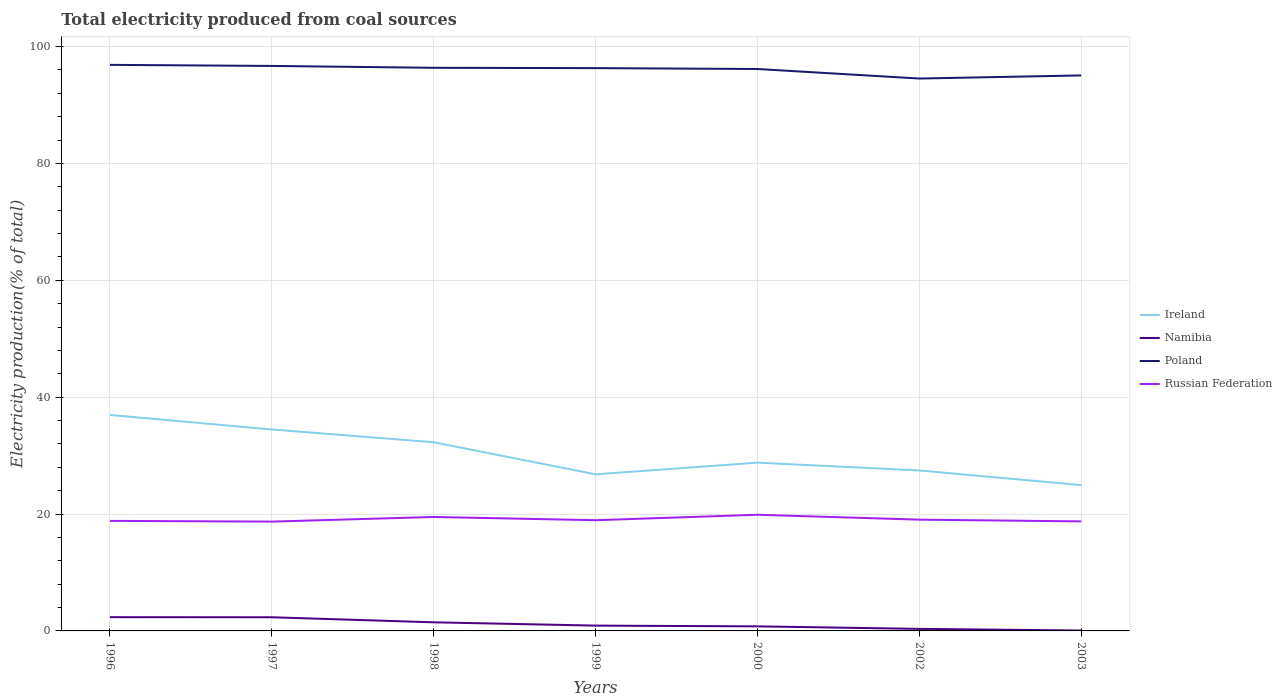How many different coloured lines are there?
Your answer should be compact. 4. Does the line corresponding to Ireland intersect with the line corresponding to Poland?
Offer a terse response. No. Is the number of lines equal to the number of legend labels?
Your answer should be compact. Yes. Across all years, what is the maximum total electricity produced in Namibia?
Provide a succinct answer. 0.07. What is the total total electricity produced in Namibia in the graph?
Provide a succinct answer. 0.69. What is the difference between the highest and the second highest total electricity produced in Poland?
Your answer should be very brief. 2.34. Is the total electricity produced in Ireland strictly greater than the total electricity produced in Poland over the years?
Your answer should be very brief. Yes. Does the graph contain grids?
Ensure brevity in your answer.  Yes. Where does the legend appear in the graph?
Provide a short and direct response. Center right. How many legend labels are there?
Provide a succinct answer. 4. What is the title of the graph?
Your answer should be very brief. Total electricity produced from coal sources. What is the label or title of the X-axis?
Ensure brevity in your answer.  Years. What is the label or title of the Y-axis?
Your answer should be compact. Electricity production(% of total). What is the Electricity production(% of total) in Ireland in 1996?
Give a very brief answer. 36.96. What is the Electricity production(% of total) of Namibia in 1996?
Make the answer very short. 2.35. What is the Electricity production(% of total) of Poland in 1996?
Make the answer very short. 96.86. What is the Electricity production(% of total) in Russian Federation in 1996?
Your answer should be compact. 18.83. What is the Electricity production(% of total) in Ireland in 1997?
Your answer should be compact. 34.47. What is the Electricity production(% of total) in Namibia in 1997?
Give a very brief answer. 2.34. What is the Electricity production(% of total) in Poland in 1997?
Offer a very short reply. 96.68. What is the Electricity production(% of total) of Russian Federation in 1997?
Keep it short and to the point. 18.7. What is the Electricity production(% of total) in Ireland in 1998?
Make the answer very short. 32.28. What is the Electricity production(% of total) in Namibia in 1998?
Ensure brevity in your answer.  1.47. What is the Electricity production(% of total) in Poland in 1998?
Provide a short and direct response. 96.36. What is the Electricity production(% of total) of Russian Federation in 1998?
Your answer should be compact. 19.5. What is the Electricity production(% of total) in Ireland in 1999?
Keep it short and to the point. 26.8. What is the Electricity production(% of total) in Namibia in 1999?
Provide a succinct answer. 0.91. What is the Electricity production(% of total) in Poland in 1999?
Keep it short and to the point. 96.3. What is the Electricity production(% of total) in Russian Federation in 1999?
Offer a terse response. 18.94. What is the Electricity production(% of total) in Ireland in 2000?
Your answer should be very brief. 28.8. What is the Electricity production(% of total) of Namibia in 2000?
Ensure brevity in your answer.  0.78. What is the Electricity production(% of total) of Poland in 2000?
Your answer should be very brief. 96.15. What is the Electricity production(% of total) in Russian Federation in 2000?
Your answer should be compact. 19.88. What is the Electricity production(% of total) of Ireland in 2002?
Give a very brief answer. 27.46. What is the Electricity production(% of total) of Namibia in 2002?
Provide a short and direct response. 0.35. What is the Electricity production(% of total) of Poland in 2002?
Your response must be concise. 94.52. What is the Electricity production(% of total) in Russian Federation in 2002?
Give a very brief answer. 19.04. What is the Electricity production(% of total) in Ireland in 2003?
Your answer should be very brief. 24.95. What is the Electricity production(% of total) of Namibia in 2003?
Your answer should be compact. 0.07. What is the Electricity production(% of total) of Poland in 2003?
Your answer should be very brief. 95.06. What is the Electricity production(% of total) of Russian Federation in 2003?
Your answer should be compact. 18.74. Across all years, what is the maximum Electricity production(% of total) of Ireland?
Offer a terse response. 36.96. Across all years, what is the maximum Electricity production(% of total) of Namibia?
Provide a short and direct response. 2.35. Across all years, what is the maximum Electricity production(% of total) of Poland?
Your answer should be compact. 96.86. Across all years, what is the maximum Electricity production(% of total) of Russian Federation?
Your answer should be very brief. 19.88. Across all years, what is the minimum Electricity production(% of total) in Ireland?
Offer a terse response. 24.95. Across all years, what is the minimum Electricity production(% of total) of Namibia?
Your response must be concise. 0.07. Across all years, what is the minimum Electricity production(% of total) of Poland?
Your answer should be compact. 94.52. Across all years, what is the minimum Electricity production(% of total) of Russian Federation?
Give a very brief answer. 18.7. What is the total Electricity production(% of total) of Ireland in the graph?
Offer a terse response. 211.71. What is the total Electricity production(% of total) in Namibia in the graph?
Your answer should be compact. 8.27. What is the total Electricity production(% of total) of Poland in the graph?
Your answer should be compact. 671.93. What is the total Electricity production(% of total) of Russian Federation in the graph?
Your answer should be compact. 133.64. What is the difference between the Electricity production(% of total) in Ireland in 1996 and that in 1997?
Make the answer very short. 2.48. What is the difference between the Electricity production(% of total) in Namibia in 1996 and that in 1997?
Give a very brief answer. 0.02. What is the difference between the Electricity production(% of total) in Poland in 1996 and that in 1997?
Offer a terse response. 0.18. What is the difference between the Electricity production(% of total) of Russian Federation in 1996 and that in 1997?
Provide a succinct answer. 0.13. What is the difference between the Electricity production(% of total) in Ireland in 1996 and that in 1998?
Your answer should be very brief. 4.67. What is the difference between the Electricity production(% of total) of Namibia in 1996 and that in 1998?
Your response must be concise. 0.88. What is the difference between the Electricity production(% of total) in Poland in 1996 and that in 1998?
Provide a succinct answer. 0.5. What is the difference between the Electricity production(% of total) of Russian Federation in 1996 and that in 1998?
Offer a very short reply. -0.67. What is the difference between the Electricity production(% of total) in Ireland in 1996 and that in 1999?
Keep it short and to the point. 10.16. What is the difference between the Electricity production(% of total) in Namibia in 1996 and that in 1999?
Offer a very short reply. 1.44. What is the difference between the Electricity production(% of total) of Poland in 1996 and that in 1999?
Provide a succinct answer. 0.56. What is the difference between the Electricity production(% of total) in Russian Federation in 1996 and that in 1999?
Keep it short and to the point. -0.11. What is the difference between the Electricity production(% of total) in Ireland in 1996 and that in 2000?
Make the answer very short. 8.16. What is the difference between the Electricity production(% of total) of Namibia in 1996 and that in 2000?
Provide a succinct answer. 1.57. What is the difference between the Electricity production(% of total) of Poland in 1996 and that in 2000?
Provide a short and direct response. 0.71. What is the difference between the Electricity production(% of total) in Russian Federation in 1996 and that in 2000?
Keep it short and to the point. -1.05. What is the difference between the Electricity production(% of total) of Ireland in 1996 and that in 2002?
Provide a succinct answer. 9.5. What is the difference between the Electricity production(% of total) of Namibia in 1996 and that in 2002?
Ensure brevity in your answer.  2. What is the difference between the Electricity production(% of total) of Poland in 1996 and that in 2002?
Give a very brief answer. 2.34. What is the difference between the Electricity production(% of total) in Russian Federation in 1996 and that in 2002?
Offer a terse response. -0.21. What is the difference between the Electricity production(% of total) of Ireland in 1996 and that in 2003?
Give a very brief answer. 12. What is the difference between the Electricity production(% of total) in Namibia in 1996 and that in 2003?
Provide a succinct answer. 2.28. What is the difference between the Electricity production(% of total) in Poland in 1996 and that in 2003?
Provide a succinct answer. 1.81. What is the difference between the Electricity production(% of total) of Russian Federation in 1996 and that in 2003?
Your answer should be very brief. 0.09. What is the difference between the Electricity production(% of total) of Ireland in 1997 and that in 1998?
Keep it short and to the point. 2.19. What is the difference between the Electricity production(% of total) of Namibia in 1997 and that in 1998?
Keep it short and to the point. 0.86. What is the difference between the Electricity production(% of total) in Poland in 1997 and that in 1998?
Provide a short and direct response. 0.32. What is the difference between the Electricity production(% of total) in Russian Federation in 1997 and that in 1998?
Keep it short and to the point. -0.79. What is the difference between the Electricity production(% of total) of Ireland in 1997 and that in 1999?
Offer a very short reply. 7.68. What is the difference between the Electricity production(% of total) of Namibia in 1997 and that in 1999?
Offer a terse response. 1.43. What is the difference between the Electricity production(% of total) in Russian Federation in 1997 and that in 1999?
Ensure brevity in your answer.  -0.24. What is the difference between the Electricity production(% of total) in Ireland in 1997 and that in 2000?
Offer a terse response. 5.67. What is the difference between the Electricity production(% of total) in Namibia in 1997 and that in 2000?
Keep it short and to the point. 1.55. What is the difference between the Electricity production(% of total) of Poland in 1997 and that in 2000?
Ensure brevity in your answer.  0.52. What is the difference between the Electricity production(% of total) of Russian Federation in 1997 and that in 2000?
Offer a terse response. -1.17. What is the difference between the Electricity production(% of total) in Ireland in 1997 and that in 2002?
Your answer should be very brief. 7.01. What is the difference between the Electricity production(% of total) of Namibia in 1997 and that in 2002?
Offer a very short reply. 1.99. What is the difference between the Electricity production(% of total) of Poland in 1997 and that in 2002?
Offer a very short reply. 2.16. What is the difference between the Electricity production(% of total) in Russian Federation in 1997 and that in 2002?
Keep it short and to the point. -0.33. What is the difference between the Electricity production(% of total) of Ireland in 1997 and that in 2003?
Your answer should be compact. 9.52. What is the difference between the Electricity production(% of total) of Namibia in 1997 and that in 2003?
Give a very brief answer. 2.27. What is the difference between the Electricity production(% of total) in Poland in 1997 and that in 2003?
Make the answer very short. 1.62. What is the difference between the Electricity production(% of total) of Russian Federation in 1997 and that in 2003?
Ensure brevity in your answer.  -0.04. What is the difference between the Electricity production(% of total) of Ireland in 1998 and that in 1999?
Offer a very short reply. 5.49. What is the difference between the Electricity production(% of total) in Namibia in 1998 and that in 1999?
Make the answer very short. 0.56. What is the difference between the Electricity production(% of total) in Poland in 1998 and that in 1999?
Your answer should be very brief. 0.06. What is the difference between the Electricity production(% of total) of Russian Federation in 1998 and that in 1999?
Your answer should be compact. 0.55. What is the difference between the Electricity production(% of total) of Ireland in 1998 and that in 2000?
Give a very brief answer. 3.49. What is the difference between the Electricity production(% of total) of Namibia in 1998 and that in 2000?
Provide a succinct answer. 0.69. What is the difference between the Electricity production(% of total) of Poland in 1998 and that in 2000?
Ensure brevity in your answer.  0.21. What is the difference between the Electricity production(% of total) in Russian Federation in 1998 and that in 2000?
Ensure brevity in your answer.  -0.38. What is the difference between the Electricity production(% of total) of Ireland in 1998 and that in 2002?
Make the answer very short. 4.83. What is the difference between the Electricity production(% of total) in Namibia in 1998 and that in 2002?
Give a very brief answer. 1.12. What is the difference between the Electricity production(% of total) in Poland in 1998 and that in 2002?
Make the answer very short. 1.84. What is the difference between the Electricity production(% of total) in Russian Federation in 1998 and that in 2002?
Your response must be concise. 0.46. What is the difference between the Electricity production(% of total) of Ireland in 1998 and that in 2003?
Keep it short and to the point. 7.33. What is the difference between the Electricity production(% of total) of Namibia in 1998 and that in 2003?
Keep it short and to the point. 1.4. What is the difference between the Electricity production(% of total) of Poland in 1998 and that in 2003?
Provide a short and direct response. 1.3. What is the difference between the Electricity production(% of total) of Russian Federation in 1998 and that in 2003?
Give a very brief answer. 0.76. What is the difference between the Electricity production(% of total) of Ireland in 1999 and that in 2000?
Ensure brevity in your answer.  -2. What is the difference between the Electricity production(% of total) of Namibia in 1999 and that in 2000?
Offer a very short reply. 0.13. What is the difference between the Electricity production(% of total) in Poland in 1999 and that in 2000?
Your response must be concise. 0.15. What is the difference between the Electricity production(% of total) of Russian Federation in 1999 and that in 2000?
Offer a very short reply. -0.93. What is the difference between the Electricity production(% of total) in Ireland in 1999 and that in 2002?
Offer a very short reply. -0.66. What is the difference between the Electricity production(% of total) of Namibia in 1999 and that in 2002?
Your answer should be very brief. 0.56. What is the difference between the Electricity production(% of total) of Poland in 1999 and that in 2002?
Offer a very short reply. 1.78. What is the difference between the Electricity production(% of total) of Russian Federation in 1999 and that in 2002?
Offer a terse response. -0.09. What is the difference between the Electricity production(% of total) in Ireland in 1999 and that in 2003?
Provide a short and direct response. 1.84. What is the difference between the Electricity production(% of total) in Namibia in 1999 and that in 2003?
Give a very brief answer. 0.84. What is the difference between the Electricity production(% of total) in Poland in 1999 and that in 2003?
Offer a terse response. 1.25. What is the difference between the Electricity production(% of total) of Russian Federation in 1999 and that in 2003?
Your answer should be compact. 0.2. What is the difference between the Electricity production(% of total) of Ireland in 2000 and that in 2002?
Provide a short and direct response. 1.34. What is the difference between the Electricity production(% of total) in Namibia in 2000 and that in 2002?
Your answer should be very brief. 0.43. What is the difference between the Electricity production(% of total) in Poland in 2000 and that in 2002?
Provide a succinct answer. 1.63. What is the difference between the Electricity production(% of total) of Russian Federation in 2000 and that in 2002?
Offer a very short reply. 0.84. What is the difference between the Electricity production(% of total) in Ireland in 2000 and that in 2003?
Your answer should be very brief. 3.85. What is the difference between the Electricity production(% of total) in Namibia in 2000 and that in 2003?
Your response must be concise. 0.71. What is the difference between the Electricity production(% of total) in Poland in 2000 and that in 2003?
Your answer should be very brief. 1.1. What is the difference between the Electricity production(% of total) in Russian Federation in 2000 and that in 2003?
Offer a terse response. 1.14. What is the difference between the Electricity production(% of total) of Ireland in 2002 and that in 2003?
Provide a succinct answer. 2.51. What is the difference between the Electricity production(% of total) in Namibia in 2002 and that in 2003?
Offer a terse response. 0.28. What is the difference between the Electricity production(% of total) of Poland in 2002 and that in 2003?
Your answer should be compact. -0.53. What is the difference between the Electricity production(% of total) of Russian Federation in 2002 and that in 2003?
Make the answer very short. 0.3. What is the difference between the Electricity production(% of total) in Ireland in 1996 and the Electricity production(% of total) in Namibia in 1997?
Provide a short and direct response. 34.62. What is the difference between the Electricity production(% of total) in Ireland in 1996 and the Electricity production(% of total) in Poland in 1997?
Offer a very short reply. -59.72. What is the difference between the Electricity production(% of total) in Ireland in 1996 and the Electricity production(% of total) in Russian Federation in 1997?
Your response must be concise. 18.25. What is the difference between the Electricity production(% of total) of Namibia in 1996 and the Electricity production(% of total) of Poland in 1997?
Provide a short and direct response. -94.33. What is the difference between the Electricity production(% of total) in Namibia in 1996 and the Electricity production(% of total) in Russian Federation in 1997?
Give a very brief answer. -16.35. What is the difference between the Electricity production(% of total) of Poland in 1996 and the Electricity production(% of total) of Russian Federation in 1997?
Ensure brevity in your answer.  78.16. What is the difference between the Electricity production(% of total) of Ireland in 1996 and the Electricity production(% of total) of Namibia in 1998?
Provide a short and direct response. 35.48. What is the difference between the Electricity production(% of total) of Ireland in 1996 and the Electricity production(% of total) of Poland in 1998?
Keep it short and to the point. -59.4. What is the difference between the Electricity production(% of total) of Ireland in 1996 and the Electricity production(% of total) of Russian Federation in 1998?
Ensure brevity in your answer.  17.46. What is the difference between the Electricity production(% of total) of Namibia in 1996 and the Electricity production(% of total) of Poland in 1998?
Offer a terse response. -94.01. What is the difference between the Electricity production(% of total) in Namibia in 1996 and the Electricity production(% of total) in Russian Federation in 1998?
Keep it short and to the point. -17.15. What is the difference between the Electricity production(% of total) in Poland in 1996 and the Electricity production(% of total) in Russian Federation in 1998?
Your answer should be very brief. 77.36. What is the difference between the Electricity production(% of total) of Ireland in 1996 and the Electricity production(% of total) of Namibia in 1999?
Keep it short and to the point. 36.05. What is the difference between the Electricity production(% of total) of Ireland in 1996 and the Electricity production(% of total) of Poland in 1999?
Your response must be concise. -59.35. What is the difference between the Electricity production(% of total) of Ireland in 1996 and the Electricity production(% of total) of Russian Federation in 1999?
Offer a very short reply. 18.01. What is the difference between the Electricity production(% of total) in Namibia in 1996 and the Electricity production(% of total) in Poland in 1999?
Provide a short and direct response. -93.95. What is the difference between the Electricity production(% of total) in Namibia in 1996 and the Electricity production(% of total) in Russian Federation in 1999?
Your answer should be very brief. -16.59. What is the difference between the Electricity production(% of total) in Poland in 1996 and the Electricity production(% of total) in Russian Federation in 1999?
Provide a succinct answer. 77.92. What is the difference between the Electricity production(% of total) of Ireland in 1996 and the Electricity production(% of total) of Namibia in 2000?
Your answer should be compact. 36.17. What is the difference between the Electricity production(% of total) of Ireland in 1996 and the Electricity production(% of total) of Poland in 2000?
Your answer should be very brief. -59.2. What is the difference between the Electricity production(% of total) in Ireland in 1996 and the Electricity production(% of total) in Russian Federation in 2000?
Keep it short and to the point. 17.08. What is the difference between the Electricity production(% of total) in Namibia in 1996 and the Electricity production(% of total) in Poland in 2000?
Your answer should be compact. -93.8. What is the difference between the Electricity production(% of total) of Namibia in 1996 and the Electricity production(% of total) of Russian Federation in 2000?
Give a very brief answer. -17.53. What is the difference between the Electricity production(% of total) in Poland in 1996 and the Electricity production(% of total) in Russian Federation in 2000?
Your answer should be compact. 76.99. What is the difference between the Electricity production(% of total) in Ireland in 1996 and the Electricity production(% of total) in Namibia in 2002?
Keep it short and to the point. 36.61. What is the difference between the Electricity production(% of total) in Ireland in 1996 and the Electricity production(% of total) in Poland in 2002?
Your response must be concise. -57.57. What is the difference between the Electricity production(% of total) of Ireland in 1996 and the Electricity production(% of total) of Russian Federation in 2002?
Your answer should be compact. 17.92. What is the difference between the Electricity production(% of total) in Namibia in 1996 and the Electricity production(% of total) in Poland in 2002?
Your response must be concise. -92.17. What is the difference between the Electricity production(% of total) in Namibia in 1996 and the Electricity production(% of total) in Russian Federation in 2002?
Your response must be concise. -16.69. What is the difference between the Electricity production(% of total) in Poland in 1996 and the Electricity production(% of total) in Russian Federation in 2002?
Your response must be concise. 77.82. What is the difference between the Electricity production(% of total) of Ireland in 1996 and the Electricity production(% of total) of Namibia in 2003?
Provide a short and direct response. 36.89. What is the difference between the Electricity production(% of total) in Ireland in 1996 and the Electricity production(% of total) in Poland in 2003?
Your answer should be very brief. -58.1. What is the difference between the Electricity production(% of total) of Ireland in 1996 and the Electricity production(% of total) of Russian Federation in 2003?
Make the answer very short. 18.21. What is the difference between the Electricity production(% of total) of Namibia in 1996 and the Electricity production(% of total) of Poland in 2003?
Offer a terse response. -92.7. What is the difference between the Electricity production(% of total) of Namibia in 1996 and the Electricity production(% of total) of Russian Federation in 2003?
Provide a short and direct response. -16.39. What is the difference between the Electricity production(% of total) of Poland in 1996 and the Electricity production(% of total) of Russian Federation in 2003?
Give a very brief answer. 78.12. What is the difference between the Electricity production(% of total) of Ireland in 1997 and the Electricity production(% of total) of Namibia in 1998?
Offer a very short reply. 33. What is the difference between the Electricity production(% of total) in Ireland in 1997 and the Electricity production(% of total) in Poland in 1998?
Your response must be concise. -61.89. What is the difference between the Electricity production(% of total) in Ireland in 1997 and the Electricity production(% of total) in Russian Federation in 1998?
Provide a succinct answer. 14.97. What is the difference between the Electricity production(% of total) of Namibia in 1997 and the Electricity production(% of total) of Poland in 1998?
Your answer should be very brief. -94.02. What is the difference between the Electricity production(% of total) in Namibia in 1997 and the Electricity production(% of total) in Russian Federation in 1998?
Offer a terse response. -17.16. What is the difference between the Electricity production(% of total) in Poland in 1997 and the Electricity production(% of total) in Russian Federation in 1998?
Offer a terse response. 77.18. What is the difference between the Electricity production(% of total) in Ireland in 1997 and the Electricity production(% of total) in Namibia in 1999?
Your response must be concise. 33.56. What is the difference between the Electricity production(% of total) in Ireland in 1997 and the Electricity production(% of total) in Poland in 1999?
Provide a short and direct response. -61.83. What is the difference between the Electricity production(% of total) in Ireland in 1997 and the Electricity production(% of total) in Russian Federation in 1999?
Keep it short and to the point. 15.53. What is the difference between the Electricity production(% of total) in Namibia in 1997 and the Electricity production(% of total) in Poland in 1999?
Offer a terse response. -93.97. What is the difference between the Electricity production(% of total) of Namibia in 1997 and the Electricity production(% of total) of Russian Federation in 1999?
Give a very brief answer. -16.61. What is the difference between the Electricity production(% of total) in Poland in 1997 and the Electricity production(% of total) in Russian Federation in 1999?
Provide a succinct answer. 77.73. What is the difference between the Electricity production(% of total) in Ireland in 1997 and the Electricity production(% of total) in Namibia in 2000?
Provide a short and direct response. 33.69. What is the difference between the Electricity production(% of total) of Ireland in 1997 and the Electricity production(% of total) of Poland in 2000?
Keep it short and to the point. -61.68. What is the difference between the Electricity production(% of total) of Ireland in 1997 and the Electricity production(% of total) of Russian Federation in 2000?
Give a very brief answer. 14.59. What is the difference between the Electricity production(% of total) of Namibia in 1997 and the Electricity production(% of total) of Poland in 2000?
Offer a terse response. -93.82. What is the difference between the Electricity production(% of total) in Namibia in 1997 and the Electricity production(% of total) in Russian Federation in 2000?
Your response must be concise. -17.54. What is the difference between the Electricity production(% of total) in Poland in 1997 and the Electricity production(% of total) in Russian Federation in 2000?
Ensure brevity in your answer.  76.8. What is the difference between the Electricity production(% of total) in Ireland in 1997 and the Electricity production(% of total) in Namibia in 2002?
Provide a succinct answer. 34.12. What is the difference between the Electricity production(% of total) in Ireland in 1997 and the Electricity production(% of total) in Poland in 2002?
Provide a succinct answer. -60.05. What is the difference between the Electricity production(% of total) in Ireland in 1997 and the Electricity production(% of total) in Russian Federation in 2002?
Give a very brief answer. 15.43. What is the difference between the Electricity production(% of total) in Namibia in 1997 and the Electricity production(% of total) in Poland in 2002?
Offer a very short reply. -92.19. What is the difference between the Electricity production(% of total) of Namibia in 1997 and the Electricity production(% of total) of Russian Federation in 2002?
Your answer should be very brief. -16.7. What is the difference between the Electricity production(% of total) of Poland in 1997 and the Electricity production(% of total) of Russian Federation in 2002?
Keep it short and to the point. 77.64. What is the difference between the Electricity production(% of total) of Ireland in 1997 and the Electricity production(% of total) of Namibia in 2003?
Provide a succinct answer. 34.4. What is the difference between the Electricity production(% of total) in Ireland in 1997 and the Electricity production(% of total) in Poland in 2003?
Offer a very short reply. -60.58. What is the difference between the Electricity production(% of total) in Ireland in 1997 and the Electricity production(% of total) in Russian Federation in 2003?
Your response must be concise. 15.73. What is the difference between the Electricity production(% of total) in Namibia in 1997 and the Electricity production(% of total) in Poland in 2003?
Give a very brief answer. -92.72. What is the difference between the Electricity production(% of total) in Namibia in 1997 and the Electricity production(% of total) in Russian Federation in 2003?
Offer a terse response. -16.4. What is the difference between the Electricity production(% of total) of Poland in 1997 and the Electricity production(% of total) of Russian Federation in 2003?
Offer a terse response. 77.94. What is the difference between the Electricity production(% of total) of Ireland in 1998 and the Electricity production(% of total) of Namibia in 1999?
Ensure brevity in your answer.  31.37. What is the difference between the Electricity production(% of total) of Ireland in 1998 and the Electricity production(% of total) of Poland in 1999?
Your answer should be very brief. -64.02. What is the difference between the Electricity production(% of total) of Ireland in 1998 and the Electricity production(% of total) of Russian Federation in 1999?
Ensure brevity in your answer.  13.34. What is the difference between the Electricity production(% of total) in Namibia in 1998 and the Electricity production(% of total) in Poland in 1999?
Your answer should be compact. -94.83. What is the difference between the Electricity production(% of total) in Namibia in 1998 and the Electricity production(% of total) in Russian Federation in 1999?
Your answer should be very brief. -17.47. What is the difference between the Electricity production(% of total) of Poland in 1998 and the Electricity production(% of total) of Russian Federation in 1999?
Ensure brevity in your answer.  77.41. What is the difference between the Electricity production(% of total) of Ireland in 1998 and the Electricity production(% of total) of Namibia in 2000?
Your answer should be compact. 31.5. What is the difference between the Electricity production(% of total) in Ireland in 1998 and the Electricity production(% of total) in Poland in 2000?
Keep it short and to the point. -63.87. What is the difference between the Electricity production(% of total) in Ireland in 1998 and the Electricity production(% of total) in Russian Federation in 2000?
Your answer should be compact. 12.41. What is the difference between the Electricity production(% of total) of Namibia in 1998 and the Electricity production(% of total) of Poland in 2000?
Offer a terse response. -94.68. What is the difference between the Electricity production(% of total) of Namibia in 1998 and the Electricity production(% of total) of Russian Federation in 2000?
Your answer should be very brief. -18.41. What is the difference between the Electricity production(% of total) in Poland in 1998 and the Electricity production(% of total) in Russian Federation in 2000?
Ensure brevity in your answer.  76.48. What is the difference between the Electricity production(% of total) in Ireland in 1998 and the Electricity production(% of total) in Namibia in 2002?
Ensure brevity in your answer.  31.93. What is the difference between the Electricity production(% of total) of Ireland in 1998 and the Electricity production(% of total) of Poland in 2002?
Offer a terse response. -62.24. What is the difference between the Electricity production(% of total) of Ireland in 1998 and the Electricity production(% of total) of Russian Federation in 2002?
Keep it short and to the point. 13.24. What is the difference between the Electricity production(% of total) of Namibia in 1998 and the Electricity production(% of total) of Poland in 2002?
Your answer should be very brief. -93.05. What is the difference between the Electricity production(% of total) of Namibia in 1998 and the Electricity production(% of total) of Russian Federation in 2002?
Offer a very short reply. -17.57. What is the difference between the Electricity production(% of total) in Poland in 1998 and the Electricity production(% of total) in Russian Federation in 2002?
Offer a very short reply. 77.32. What is the difference between the Electricity production(% of total) of Ireland in 1998 and the Electricity production(% of total) of Namibia in 2003?
Provide a short and direct response. 32.21. What is the difference between the Electricity production(% of total) in Ireland in 1998 and the Electricity production(% of total) in Poland in 2003?
Keep it short and to the point. -62.77. What is the difference between the Electricity production(% of total) of Ireland in 1998 and the Electricity production(% of total) of Russian Federation in 2003?
Offer a terse response. 13.54. What is the difference between the Electricity production(% of total) of Namibia in 1998 and the Electricity production(% of total) of Poland in 2003?
Give a very brief answer. -93.58. What is the difference between the Electricity production(% of total) in Namibia in 1998 and the Electricity production(% of total) in Russian Federation in 2003?
Your response must be concise. -17.27. What is the difference between the Electricity production(% of total) in Poland in 1998 and the Electricity production(% of total) in Russian Federation in 2003?
Offer a very short reply. 77.62. What is the difference between the Electricity production(% of total) of Ireland in 1999 and the Electricity production(% of total) of Namibia in 2000?
Give a very brief answer. 26.01. What is the difference between the Electricity production(% of total) in Ireland in 1999 and the Electricity production(% of total) in Poland in 2000?
Your answer should be compact. -69.36. What is the difference between the Electricity production(% of total) in Ireland in 1999 and the Electricity production(% of total) in Russian Federation in 2000?
Your response must be concise. 6.92. What is the difference between the Electricity production(% of total) in Namibia in 1999 and the Electricity production(% of total) in Poland in 2000?
Your response must be concise. -95.24. What is the difference between the Electricity production(% of total) of Namibia in 1999 and the Electricity production(% of total) of Russian Federation in 2000?
Provide a short and direct response. -18.97. What is the difference between the Electricity production(% of total) in Poland in 1999 and the Electricity production(% of total) in Russian Federation in 2000?
Provide a succinct answer. 76.43. What is the difference between the Electricity production(% of total) of Ireland in 1999 and the Electricity production(% of total) of Namibia in 2002?
Offer a very short reply. 26.45. What is the difference between the Electricity production(% of total) in Ireland in 1999 and the Electricity production(% of total) in Poland in 2002?
Offer a terse response. -67.73. What is the difference between the Electricity production(% of total) of Ireland in 1999 and the Electricity production(% of total) of Russian Federation in 2002?
Your response must be concise. 7.76. What is the difference between the Electricity production(% of total) in Namibia in 1999 and the Electricity production(% of total) in Poland in 2002?
Provide a short and direct response. -93.61. What is the difference between the Electricity production(% of total) of Namibia in 1999 and the Electricity production(% of total) of Russian Federation in 2002?
Ensure brevity in your answer.  -18.13. What is the difference between the Electricity production(% of total) of Poland in 1999 and the Electricity production(% of total) of Russian Federation in 2002?
Provide a short and direct response. 77.26. What is the difference between the Electricity production(% of total) in Ireland in 1999 and the Electricity production(% of total) in Namibia in 2003?
Make the answer very short. 26.72. What is the difference between the Electricity production(% of total) in Ireland in 1999 and the Electricity production(% of total) in Poland in 2003?
Ensure brevity in your answer.  -68.26. What is the difference between the Electricity production(% of total) in Ireland in 1999 and the Electricity production(% of total) in Russian Federation in 2003?
Give a very brief answer. 8.05. What is the difference between the Electricity production(% of total) in Namibia in 1999 and the Electricity production(% of total) in Poland in 2003?
Your answer should be compact. -94.15. What is the difference between the Electricity production(% of total) of Namibia in 1999 and the Electricity production(% of total) of Russian Federation in 2003?
Keep it short and to the point. -17.83. What is the difference between the Electricity production(% of total) in Poland in 1999 and the Electricity production(% of total) in Russian Federation in 2003?
Your answer should be very brief. 77.56. What is the difference between the Electricity production(% of total) of Ireland in 2000 and the Electricity production(% of total) of Namibia in 2002?
Your answer should be very brief. 28.45. What is the difference between the Electricity production(% of total) in Ireland in 2000 and the Electricity production(% of total) in Poland in 2002?
Ensure brevity in your answer.  -65.73. What is the difference between the Electricity production(% of total) in Ireland in 2000 and the Electricity production(% of total) in Russian Federation in 2002?
Offer a very short reply. 9.76. What is the difference between the Electricity production(% of total) of Namibia in 2000 and the Electricity production(% of total) of Poland in 2002?
Your answer should be very brief. -93.74. What is the difference between the Electricity production(% of total) in Namibia in 2000 and the Electricity production(% of total) in Russian Federation in 2002?
Give a very brief answer. -18.26. What is the difference between the Electricity production(% of total) in Poland in 2000 and the Electricity production(% of total) in Russian Federation in 2002?
Make the answer very short. 77.12. What is the difference between the Electricity production(% of total) in Ireland in 2000 and the Electricity production(% of total) in Namibia in 2003?
Your answer should be compact. 28.73. What is the difference between the Electricity production(% of total) of Ireland in 2000 and the Electricity production(% of total) of Poland in 2003?
Your answer should be compact. -66.26. What is the difference between the Electricity production(% of total) in Ireland in 2000 and the Electricity production(% of total) in Russian Federation in 2003?
Your response must be concise. 10.06. What is the difference between the Electricity production(% of total) of Namibia in 2000 and the Electricity production(% of total) of Poland in 2003?
Your response must be concise. -94.27. What is the difference between the Electricity production(% of total) of Namibia in 2000 and the Electricity production(% of total) of Russian Federation in 2003?
Your answer should be compact. -17.96. What is the difference between the Electricity production(% of total) in Poland in 2000 and the Electricity production(% of total) in Russian Federation in 2003?
Offer a terse response. 77.41. What is the difference between the Electricity production(% of total) in Ireland in 2002 and the Electricity production(% of total) in Namibia in 2003?
Provide a short and direct response. 27.39. What is the difference between the Electricity production(% of total) of Ireland in 2002 and the Electricity production(% of total) of Poland in 2003?
Ensure brevity in your answer.  -67.6. What is the difference between the Electricity production(% of total) in Ireland in 2002 and the Electricity production(% of total) in Russian Federation in 2003?
Offer a very short reply. 8.72. What is the difference between the Electricity production(% of total) in Namibia in 2002 and the Electricity production(% of total) in Poland in 2003?
Your answer should be compact. -94.71. What is the difference between the Electricity production(% of total) of Namibia in 2002 and the Electricity production(% of total) of Russian Federation in 2003?
Provide a succinct answer. -18.39. What is the difference between the Electricity production(% of total) in Poland in 2002 and the Electricity production(% of total) in Russian Federation in 2003?
Make the answer very short. 75.78. What is the average Electricity production(% of total) in Ireland per year?
Provide a succinct answer. 30.24. What is the average Electricity production(% of total) in Namibia per year?
Ensure brevity in your answer.  1.18. What is the average Electricity production(% of total) in Poland per year?
Ensure brevity in your answer.  95.99. What is the average Electricity production(% of total) in Russian Federation per year?
Your response must be concise. 19.09. In the year 1996, what is the difference between the Electricity production(% of total) in Ireland and Electricity production(% of total) in Namibia?
Provide a short and direct response. 34.6. In the year 1996, what is the difference between the Electricity production(% of total) of Ireland and Electricity production(% of total) of Poland?
Make the answer very short. -59.91. In the year 1996, what is the difference between the Electricity production(% of total) in Ireland and Electricity production(% of total) in Russian Federation?
Provide a short and direct response. 18.12. In the year 1996, what is the difference between the Electricity production(% of total) of Namibia and Electricity production(% of total) of Poland?
Your answer should be compact. -94.51. In the year 1996, what is the difference between the Electricity production(% of total) in Namibia and Electricity production(% of total) in Russian Federation?
Ensure brevity in your answer.  -16.48. In the year 1996, what is the difference between the Electricity production(% of total) of Poland and Electricity production(% of total) of Russian Federation?
Keep it short and to the point. 78.03. In the year 1997, what is the difference between the Electricity production(% of total) in Ireland and Electricity production(% of total) in Namibia?
Offer a terse response. 32.13. In the year 1997, what is the difference between the Electricity production(% of total) in Ireland and Electricity production(% of total) in Poland?
Give a very brief answer. -62.21. In the year 1997, what is the difference between the Electricity production(% of total) in Ireland and Electricity production(% of total) in Russian Federation?
Give a very brief answer. 15.77. In the year 1997, what is the difference between the Electricity production(% of total) in Namibia and Electricity production(% of total) in Poland?
Your answer should be compact. -94.34. In the year 1997, what is the difference between the Electricity production(% of total) of Namibia and Electricity production(% of total) of Russian Federation?
Give a very brief answer. -16.37. In the year 1997, what is the difference between the Electricity production(% of total) in Poland and Electricity production(% of total) in Russian Federation?
Ensure brevity in your answer.  77.97. In the year 1998, what is the difference between the Electricity production(% of total) in Ireland and Electricity production(% of total) in Namibia?
Ensure brevity in your answer.  30.81. In the year 1998, what is the difference between the Electricity production(% of total) in Ireland and Electricity production(% of total) in Poland?
Offer a terse response. -64.08. In the year 1998, what is the difference between the Electricity production(% of total) of Ireland and Electricity production(% of total) of Russian Federation?
Give a very brief answer. 12.78. In the year 1998, what is the difference between the Electricity production(% of total) in Namibia and Electricity production(% of total) in Poland?
Ensure brevity in your answer.  -94.89. In the year 1998, what is the difference between the Electricity production(% of total) of Namibia and Electricity production(% of total) of Russian Federation?
Provide a succinct answer. -18.03. In the year 1998, what is the difference between the Electricity production(% of total) in Poland and Electricity production(% of total) in Russian Federation?
Ensure brevity in your answer.  76.86. In the year 1999, what is the difference between the Electricity production(% of total) of Ireland and Electricity production(% of total) of Namibia?
Offer a very short reply. 25.89. In the year 1999, what is the difference between the Electricity production(% of total) in Ireland and Electricity production(% of total) in Poland?
Your answer should be very brief. -69.51. In the year 1999, what is the difference between the Electricity production(% of total) of Ireland and Electricity production(% of total) of Russian Federation?
Keep it short and to the point. 7.85. In the year 1999, what is the difference between the Electricity production(% of total) in Namibia and Electricity production(% of total) in Poland?
Your answer should be compact. -95.39. In the year 1999, what is the difference between the Electricity production(% of total) in Namibia and Electricity production(% of total) in Russian Federation?
Your answer should be compact. -18.03. In the year 1999, what is the difference between the Electricity production(% of total) of Poland and Electricity production(% of total) of Russian Federation?
Keep it short and to the point. 77.36. In the year 2000, what is the difference between the Electricity production(% of total) of Ireland and Electricity production(% of total) of Namibia?
Your answer should be compact. 28.01. In the year 2000, what is the difference between the Electricity production(% of total) of Ireland and Electricity production(% of total) of Poland?
Provide a succinct answer. -67.36. In the year 2000, what is the difference between the Electricity production(% of total) in Ireland and Electricity production(% of total) in Russian Federation?
Make the answer very short. 8.92. In the year 2000, what is the difference between the Electricity production(% of total) of Namibia and Electricity production(% of total) of Poland?
Keep it short and to the point. -95.37. In the year 2000, what is the difference between the Electricity production(% of total) of Namibia and Electricity production(% of total) of Russian Federation?
Provide a short and direct response. -19.1. In the year 2000, what is the difference between the Electricity production(% of total) in Poland and Electricity production(% of total) in Russian Federation?
Ensure brevity in your answer.  76.28. In the year 2002, what is the difference between the Electricity production(% of total) of Ireland and Electricity production(% of total) of Namibia?
Your answer should be very brief. 27.11. In the year 2002, what is the difference between the Electricity production(% of total) of Ireland and Electricity production(% of total) of Poland?
Provide a short and direct response. -67.07. In the year 2002, what is the difference between the Electricity production(% of total) of Ireland and Electricity production(% of total) of Russian Federation?
Make the answer very short. 8.42. In the year 2002, what is the difference between the Electricity production(% of total) of Namibia and Electricity production(% of total) of Poland?
Offer a very short reply. -94.17. In the year 2002, what is the difference between the Electricity production(% of total) of Namibia and Electricity production(% of total) of Russian Federation?
Ensure brevity in your answer.  -18.69. In the year 2002, what is the difference between the Electricity production(% of total) of Poland and Electricity production(% of total) of Russian Federation?
Offer a terse response. 75.48. In the year 2003, what is the difference between the Electricity production(% of total) in Ireland and Electricity production(% of total) in Namibia?
Your answer should be compact. 24.88. In the year 2003, what is the difference between the Electricity production(% of total) of Ireland and Electricity production(% of total) of Poland?
Ensure brevity in your answer.  -70.1. In the year 2003, what is the difference between the Electricity production(% of total) of Ireland and Electricity production(% of total) of Russian Federation?
Offer a terse response. 6.21. In the year 2003, what is the difference between the Electricity production(% of total) of Namibia and Electricity production(% of total) of Poland?
Ensure brevity in your answer.  -94.99. In the year 2003, what is the difference between the Electricity production(% of total) in Namibia and Electricity production(% of total) in Russian Federation?
Provide a short and direct response. -18.67. In the year 2003, what is the difference between the Electricity production(% of total) of Poland and Electricity production(% of total) of Russian Federation?
Your answer should be very brief. 76.31. What is the ratio of the Electricity production(% of total) of Ireland in 1996 to that in 1997?
Keep it short and to the point. 1.07. What is the ratio of the Electricity production(% of total) in Russian Federation in 1996 to that in 1997?
Your answer should be compact. 1.01. What is the ratio of the Electricity production(% of total) of Ireland in 1996 to that in 1998?
Ensure brevity in your answer.  1.14. What is the ratio of the Electricity production(% of total) in Namibia in 1996 to that in 1998?
Your response must be concise. 1.6. What is the ratio of the Electricity production(% of total) of Poland in 1996 to that in 1998?
Make the answer very short. 1.01. What is the ratio of the Electricity production(% of total) of Russian Federation in 1996 to that in 1998?
Your answer should be very brief. 0.97. What is the ratio of the Electricity production(% of total) in Ireland in 1996 to that in 1999?
Your response must be concise. 1.38. What is the ratio of the Electricity production(% of total) of Namibia in 1996 to that in 1999?
Provide a succinct answer. 2.58. What is the ratio of the Electricity production(% of total) of Ireland in 1996 to that in 2000?
Ensure brevity in your answer.  1.28. What is the ratio of the Electricity production(% of total) in Namibia in 1996 to that in 2000?
Offer a very short reply. 3.01. What is the ratio of the Electricity production(% of total) of Poland in 1996 to that in 2000?
Provide a succinct answer. 1.01. What is the ratio of the Electricity production(% of total) in Ireland in 1996 to that in 2002?
Your response must be concise. 1.35. What is the ratio of the Electricity production(% of total) of Namibia in 1996 to that in 2002?
Your response must be concise. 6.72. What is the ratio of the Electricity production(% of total) of Poland in 1996 to that in 2002?
Your answer should be compact. 1.02. What is the ratio of the Electricity production(% of total) in Ireland in 1996 to that in 2003?
Provide a succinct answer. 1.48. What is the ratio of the Electricity production(% of total) of Namibia in 1996 to that in 2003?
Your answer should be very brief. 33.42. What is the ratio of the Electricity production(% of total) in Ireland in 1997 to that in 1998?
Make the answer very short. 1.07. What is the ratio of the Electricity production(% of total) of Namibia in 1997 to that in 1998?
Offer a very short reply. 1.59. What is the ratio of the Electricity production(% of total) of Poland in 1997 to that in 1998?
Ensure brevity in your answer.  1. What is the ratio of the Electricity production(% of total) of Russian Federation in 1997 to that in 1998?
Give a very brief answer. 0.96. What is the ratio of the Electricity production(% of total) of Ireland in 1997 to that in 1999?
Ensure brevity in your answer.  1.29. What is the ratio of the Electricity production(% of total) of Namibia in 1997 to that in 1999?
Make the answer very short. 2.57. What is the ratio of the Electricity production(% of total) of Poland in 1997 to that in 1999?
Provide a short and direct response. 1. What is the ratio of the Electricity production(% of total) in Russian Federation in 1997 to that in 1999?
Give a very brief answer. 0.99. What is the ratio of the Electricity production(% of total) of Ireland in 1997 to that in 2000?
Provide a succinct answer. 1.2. What is the ratio of the Electricity production(% of total) of Namibia in 1997 to that in 2000?
Your answer should be very brief. 2.99. What is the ratio of the Electricity production(% of total) in Russian Federation in 1997 to that in 2000?
Your answer should be compact. 0.94. What is the ratio of the Electricity production(% of total) in Ireland in 1997 to that in 2002?
Your response must be concise. 1.26. What is the ratio of the Electricity production(% of total) in Namibia in 1997 to that in 2002?
Ensure brevity in your answer.  6.68. What is the ratio of the Electricity production(% of total) of Poland in 1997 to that in 2002?
Ensure brevity in your answer.  1.02. What is the ratio of the Electricity production(% of total) in Russian Federation in 1997 to that in 2002?
Your response must be concise. 0.98. What is the ratio of the Electricity production(% of total) of Ireland in 1997 to that in 2003?
Provide a short and direct response. 1.38. What is the ratio of the Electricity production(% of total) in Namibia in 1997 to that in 2003?
Offer a terse response. 33.2. What is the ratio of the Electricity production(% of total) in Poland in 1997 to that in 2003?
Offer a terse response. 1.02. What is the ratio of the Electricity production(% of total) in Ireland in 1998 to that in 1999?
Your response must be concise. 1.2. What is the ratio of the Electricity production(% of total) of Namibia in 1998 to that in 1999?
Offer a terse response. 1.62. What is the ratio of the Electricity production(% of total) of Russian Federation in 1998 to that in 1999?
Offer a very short reply. 1.03. What is the ratio of the Electricity production(% of total) of Ireland in 1998 to that in 2000?
Offer a very short reply. 1.12. What is the ratio of the Electricity production(% of total) of Namibia in 1998 to that in 2000?
Provide a succinct answer. 1.88. What is the ratio of the Electricity production(% of total) of Poland in 1998 to that in 2000?
Give a very brief answer. 1. What is the ratio of the Electricity production(% of total) of Ireland in 1998 to that in 2002?
Offer a terse response. 1.18. What is the ratio of the Electricity production(% of total) in Namibia in 1998 to that in 2002?
Your answer should be very brief. 4.21. What is the ratio of the Electricity production(% of total) in Poland in 1998 to that in 2002?
Your answer should be compact. 1.02. What is the ratio of the Electricity production(% of total) in Russian Federation in 1998 to that in 2002?
Give a very brief answer. 1.02. What is the ratio of the Electricity production(% of total) in Ireland in 1998 to that in 2003?
Ensure brevity in your answer.  1.29. What is the ratio of the Electricity production(% of total) in Namibia in 1998 to that in 2003?
Give a very brief answer. 20.92. What is the ratio of the Electricity production(% of total) in Poland in 1998 to that in 2003?
Provide a short and direct response. 1.01. What is the ratio of the Electricity production(% of total) in Russian Federation in 1998 to that in 2003?
Provide a short and direct response. 1.04. What is the ratio of the Electricity production(% of total) in Ireland in 1999 to that in 2000?
Keep it short and to the point. 0.93. What is the ratio of the Electricity production(% of total) in Namibia in 1999 to that in 2000?
Your answer should be very brief. 1.16. What is the ratio of the Electricity production(% of total) in Poland in 1999 to that in 2000?
Make the answer very short. 1. What is the ratio of the Electricity production(% of total) of Russian Federation in 1999 to that in 2000?
Your answer should be very brief. 0.95. What is the ratio of the Electricity production(% of total) in Ireland in 1999 to that in 2002?
Offer a terse response. 0.98. What is the ratio of the Electricity production(% of total) in Namibia in 1999 to that in 2002?
Offer a terse response. 2.6. What is the ratio of the Electricity production(% of total) of Poland in 1999 to that in 2002?
Provide a short and direct response. 1.02. What is the ratio of the Electricity production(% of total) in Ireland in 1999 to that in 2003?
Your response must be concise. 1.07. What is the ratio of the Electricity production(% of total) of Namibia in 1999 to that in 2003?
Give a very brief answer. 12.93. What is the ratio of the Electricity production(% of total) in Poland in 1999 to that in 2003?
Offer a very short reply. 1.01. What is the ratio of the Electricity production(% of total) in Russian Federation in 1999 to that in 2003?
Your response must be concise. 1.01. What is the ratio of the Electricity production(% of total) of Ireland in 2000 to that in 2002?
Your answer should be compact. 1.05. What is the ratio of the Electricity production(% of total) of Namibia in 2000 to that in 2002?
Keep it short and to the point. 2.23. What is the ratio of the Electricity production(% of total) in Poland in 2000 to that in 2002?
Your answer should be compact. 1.02. What is the ratio of the Electricity production(% of total) of Russian Federation in 2000 to that in 2002?
Keep it short and to the point. 1.04. What is the ratio of the Electricity production(% of total) of Ireland in 2000 to that in 2003?
Provide a short and direct response. 1.15. What is the ratio of the Electricity production(% of total) in Namibia in 2000 to that in 2003?
Offer a terse response. 11.11. What is the ratio of the Electricity production(% of total) of Poland in 2000 to that in 2003?
Ensure brevity in your answer.  1.01. What is the ratio of the Electricity production(% of total) in Russian Federation in 2000 to that in 2003?
Your response must be concise. 1.06. What is the ratio of the Electricity production(% of total) of Ireland in 2002 to that in 2003?
Your response must be concise. 1.1. What is the ratio of the Electricity production(% of total) of Namibia in 2002 to that in 2003?
Your response must be concise. 4.97. What is the ratio of the Electricity production(% of total) of Poland in 2002 to that in 2003?
Make the answer very short. 0.99. What is the ratio of the Electricity production(% of total) of Russian Federation in 2002 to that in 2003?
Provide a succinct answer. 1.02. What is the difference between the highest and the second highest Electricity production(% of total) in Ireland?
Offer a terse response. 2.48. What is the difference between the highest and the second highest Electricity production(% of total) in Namibia?
Provide a short and direct response. 0.02. What is the difference between the highest and the second highest Electricity production(% of total) in Poland?
Your answer should be compact. 0.18. What is the difference between the highest and the second highest Electricity production(% of total) of Russian Federation?
Your answer should be compact. 0.38. What is the difference between the highest and the lowest Electricity production(% of total) of Ireland?
Your answer should be compact. 12. What is the difference between the highest and the lowest Electricity production(% of total) in Namibia?
Offer a terse response. 2.28. What is the difference between the highest and the lowest Electricity production(% of total) of Poland?
Ensure brevity in your answer.  2.34. What is the difference between the highest and the lowest Electricity production(% of total) of Russian Federation?
Provide a succinct answer. 1.17. 